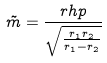Convert formula to latex. <formula><loc_0><loc_0><loc_500><loc_500>\tilde { m } = \frac { r h p } { \sqrt { \frac { r _ { 1 } r _ { 2 } } { r _ { 1 } - r _ { 2 } } } }</formula> 